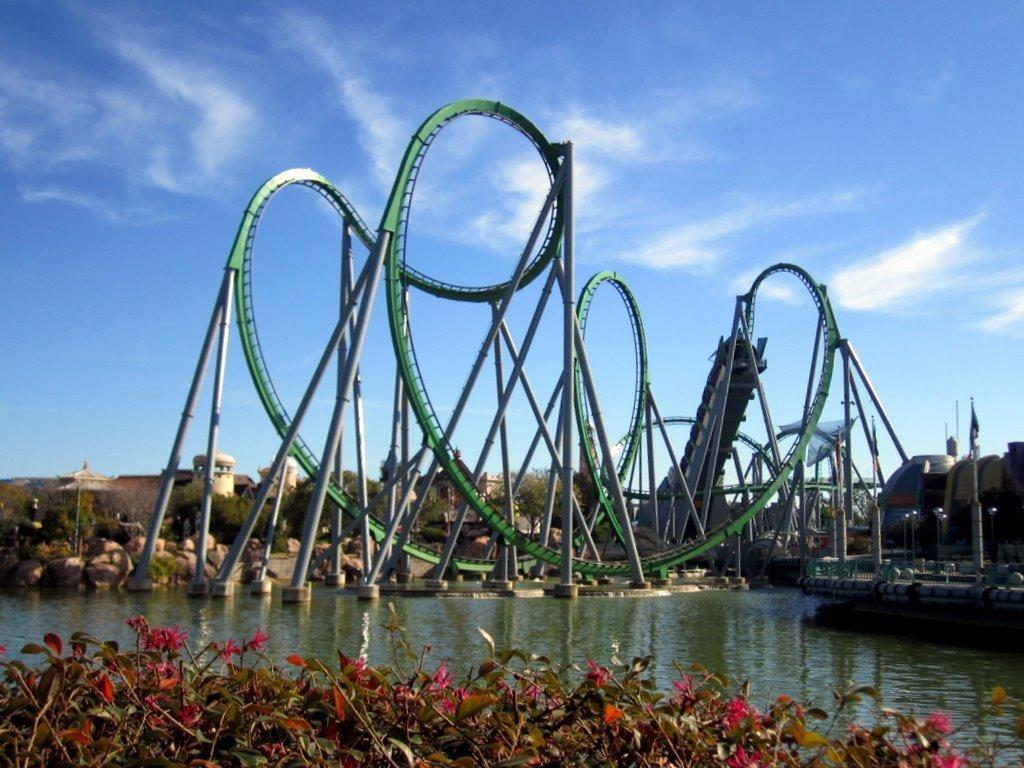In one or two sentences, can you explain what this image depicts? In this image there is a sky, there is a rollercoaster, there are rocks, there are trees, there are plants, there are flowers, there is a river. 